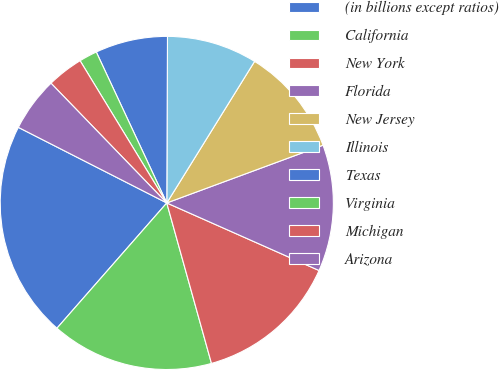Convert chart to OTSL. <chart><loc_0><loc_0><loc_500><loc_500><pie_chart><fcel>(in billions except ratios)<fcel>California<fcel>New York<fcel>Florida<fcel>New Jersey<fcel>Illinois<fcel>Texas<fcel>Virginia<fcel>Michigan<fcel>Arizona<nl><fcel>21.04%<fcel>15.78%<fcel>14.03%<fcel>12.28%<fcel>10.53%<fcel>8.77%<fcel>7.02%<fcel>1.76%<fcel>3.52%<fcel>5.27%<nl></chart> 